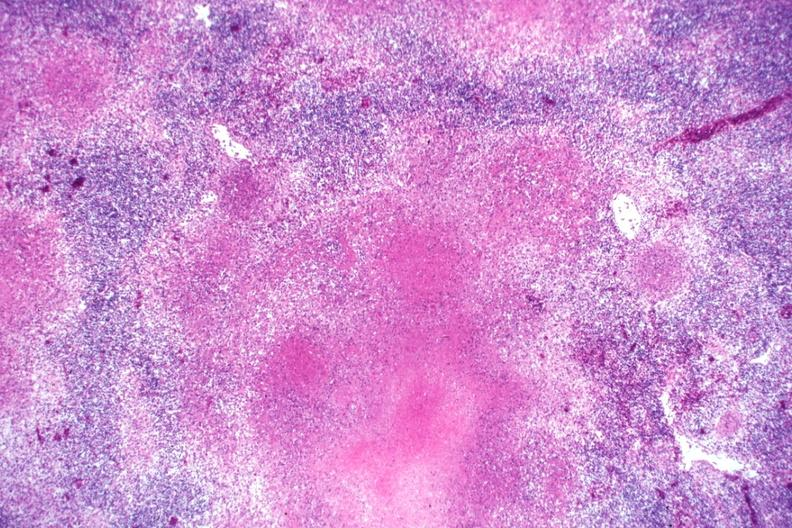what is present?
Answer the question using a single word or phrase. Tuberculosis 